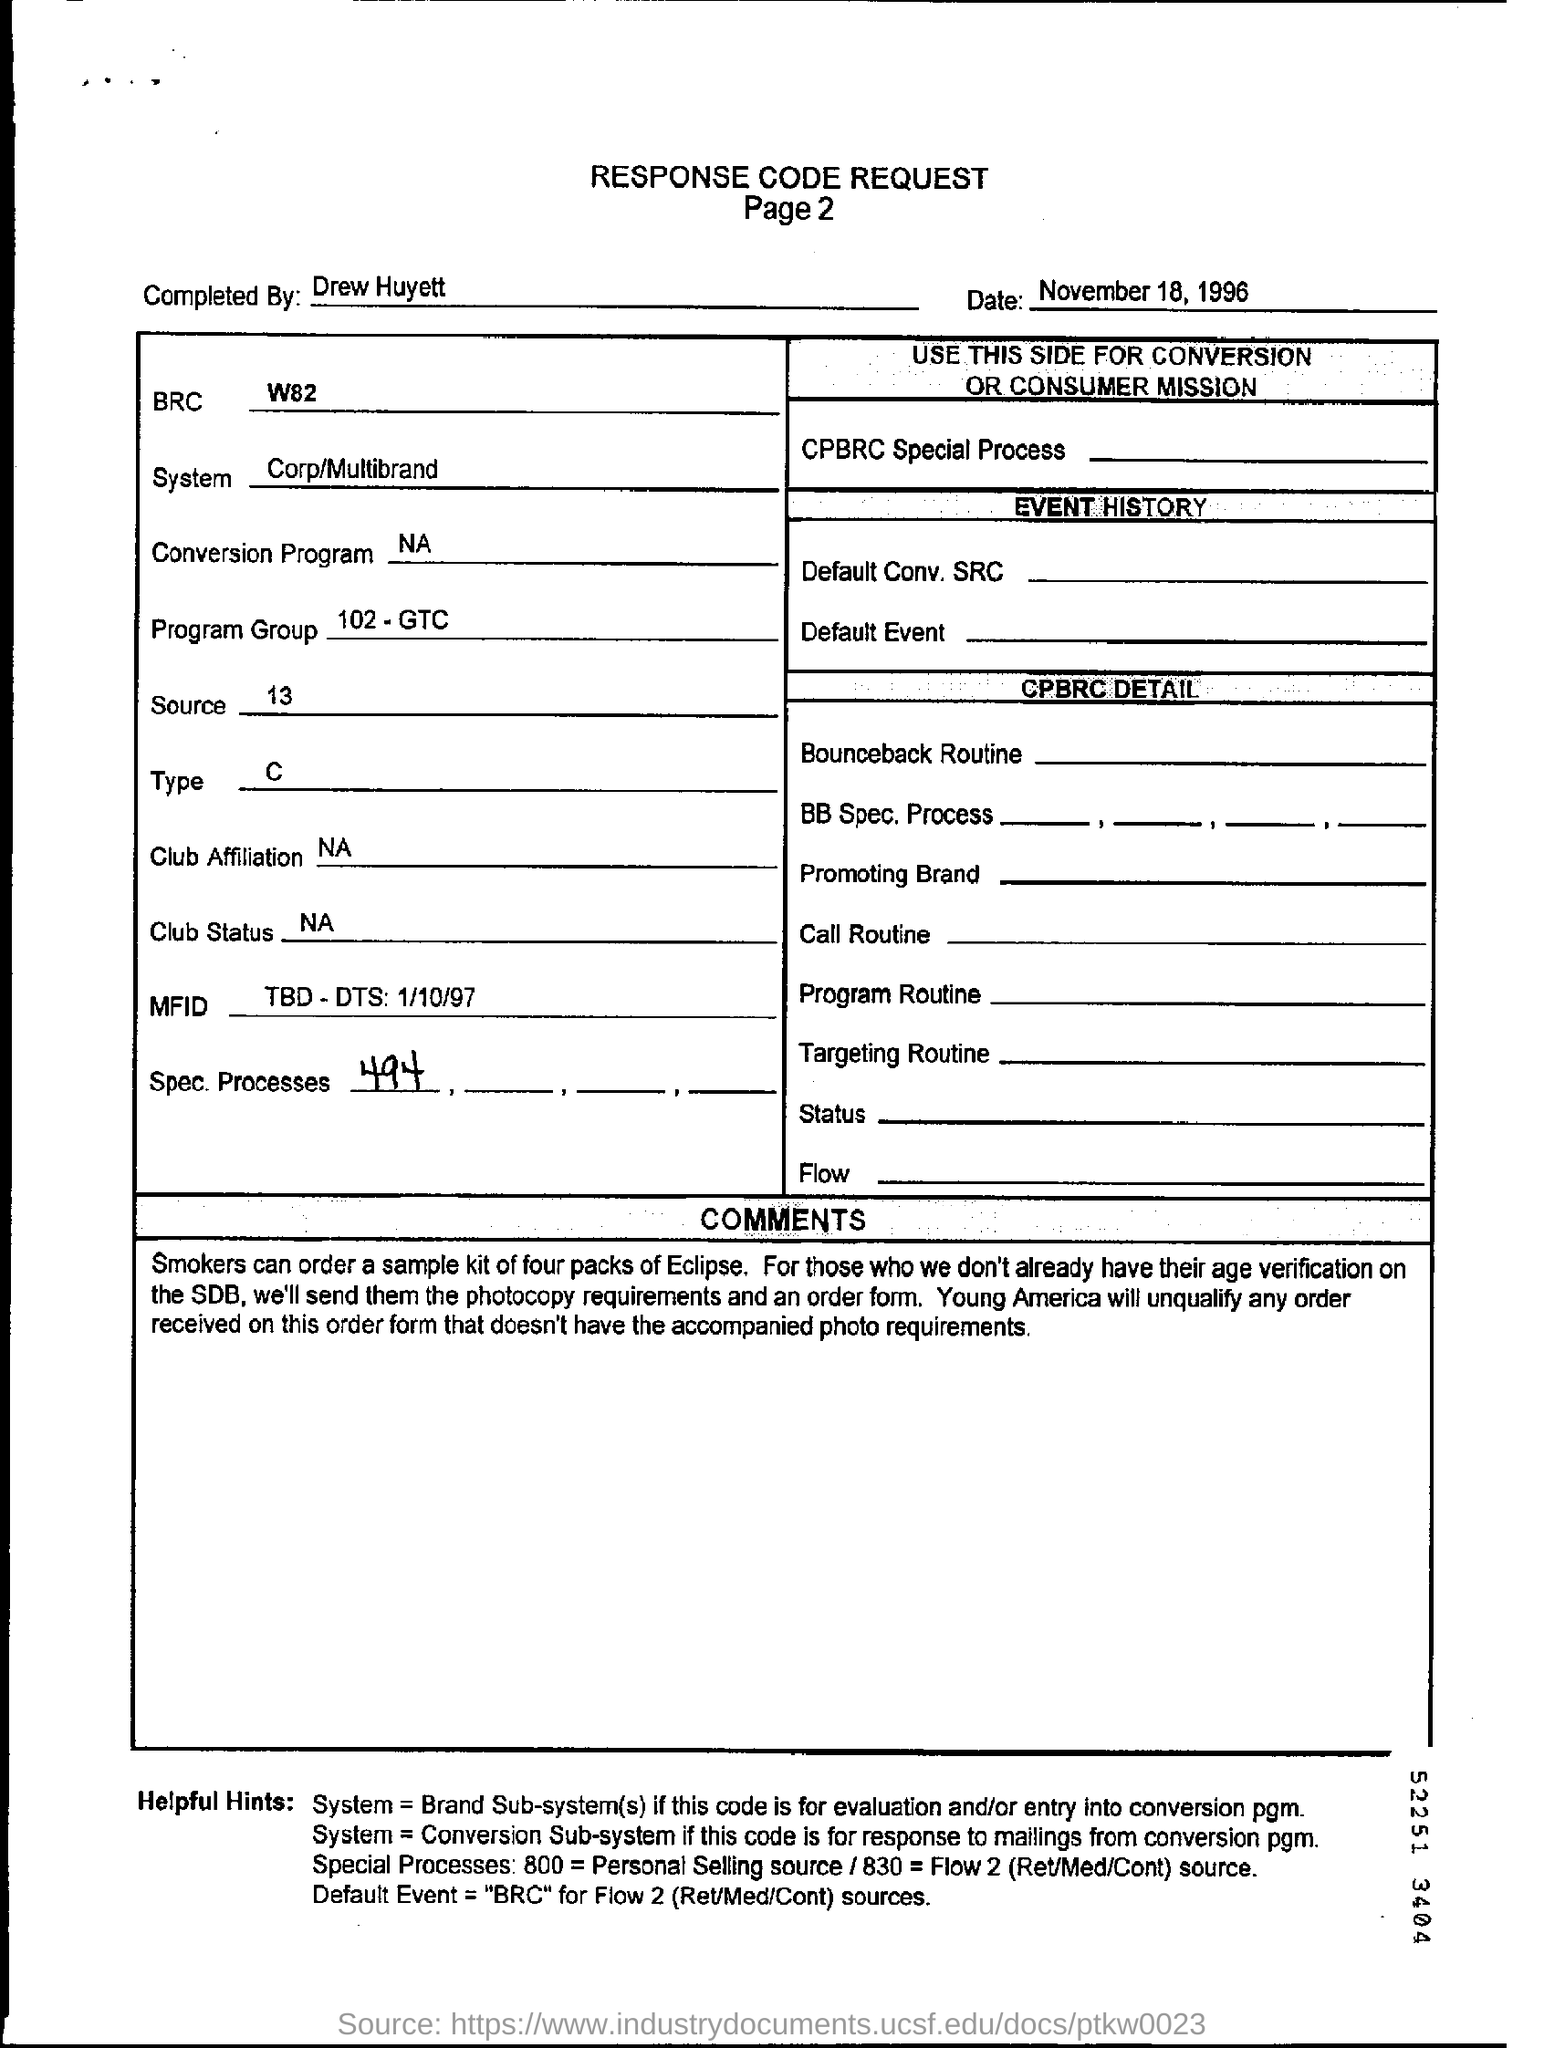What is the date mentioned in the form?
Provide a short and direct response. November 18, 1996. Who completed this request form ?
Provide a succinct answer. Drew Huyett. Which type is mentioned ?
Make the answer very short. C. 